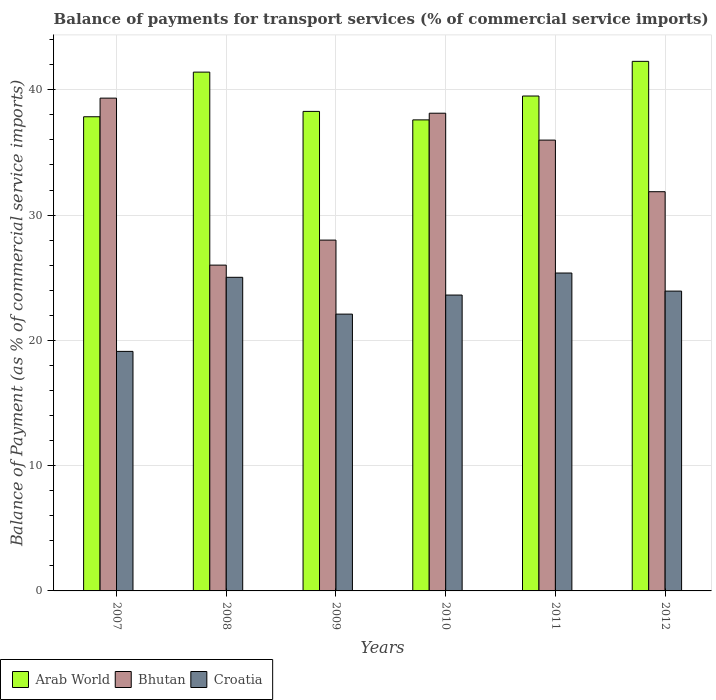Are the number of bars per tick equal to the number of legend labels?
Offer a very short reply. Yes. What is the label of the 5th group of bars from the left?
Your answer should be compact. 2011. What is the balance of payments for transport services in Bhutan in 2010?
Your response must be concise. 38.13. Across all years, what is the maximum balance of payments for transport services in Croatia?
Provide a succinct answer. 25.37. Across all years, what is the minimum balance of payments for transport services in Arab World?
Offer a very short reply. 37.6. In which year was the balance of payments for transport services in Arab World maximum?
Provide a succinct answer. 2012. What is the total balance of payments for transport services in Croatia in the graph?
Ensure brevity in your answer.  139.17. What is the difference between the balance of payments for transport services in Croatia in 2007 and that in 2008?
Provide a short and direct response. -5.91. What is the difference between the balance of payments for transport services in Arab World in 2007 and the balance of payments for transport services in Bhutan in 2012?
Provide a short and direct response. 5.98. What is the average balance of payments for transport services in Arab World per year?
Provide a succinct answer. 39.48. In the year 2007, what is the difference between the balance of payments for transport services in Croatia and balance of payments for transport services in Bhutan?
Provide a short and direct response. -20.21. What is the ratio of the balance of payments for transport services in Arab World in 2009 to that in 2010?
Make the answer very short. 1.02. Is the balance of payments for transport services in Croatia in 2008 less than that in 2009?
Your answer should be compact. No. What is the difference between the highest and the second highest balance of payments for transport services in Arab World?
Provide a succinct answer. 0.86. What is the difference between the highest and the lowest balance of payments for transport services in Arab World?
Keep it short and to the point. 4.67. In how many years, is the balance of payments for transport services in Bhutan greater than the average balance of payments for transport services in Bhutan taken over all years?
Offer a very short reply. 3. Is the sum of the balance of payments for transport services in Arab World in 2010 and 2011 greater than the maximum balance of payments for transport services in Bhutan across all years?
Your response must be concise. Yes. What does the 2nd bar from the left in 2011 represents?
Give a very brief answer. Bhutan. What does the 3rd bar from the right in 2007 represents?
Ensure brevity in your answer.  Arab World. Is it the case that in every year, the sum of the balance of payments for transport services in Croatia and balance of payments for transport services in Arab World is greater than the balance of payments for transport services in Bhutan?
Your response must be concise. Yes. Are all the bars in the graph horizontal?
Offer a terse response. No. How many years are there in the graph?
Keep it short and to the point. 6. What is the difference between two consecutive major ticks on the Y-axis?
Your response must be concise. 10. Are the values on the major ticks of Y-axis written in scientific E-notation?
Your answer should be compact. No. Does the graph contain any zero values?
Offer a very short reply. No. What is the title of the graph?
Ensure brevity in your answer.  Balance of payments for transport services (% of commercial service imports). What is the label or title of the Y-axis?
Keep it short and to the point. Balance of Payment (as % of commercial service imports). What is the Balance of Payment (as % of commercial service imports) of Arab World in 2007?
Keep it short and to the point. 37.85. What is the Balance of Payment (as % of commercial service imports) of Bhutan in 2007?
Keep it short and to the point. 39.33. What is the Balance of Payment (as % of commercial service imports) in Croatia in 2007?
Your answer should be very brief. 19.12. What is the Balance of Payment (as % of commercial service imports) in Arab World in 2008?
Your answer should be compact. 41.41. What is the Balance of Payment (as % of commercial service imports) in Bhutan in 2008?
Provide a short and direct response. 26.01. What is the Balance of Payment (as % of commercial service imports) of Croatia in 2008?
Offer a very short reply. 25.03. What is the Balance of Payment (as % of commercial service imports) of Arab World in 2009?
Offer a very short reply. 38.28. What is the Balance of Payment (as % of commercial service imports) in Bhutan in 2009?
Your response must be concise. 28. What is the Balance of Payment (as % of commercial service imports) in Croatia in 2009?
Keep it short and to the point. 22.1. What is the Balance of Payment (as % of commercial service imports) of Arab World in 2010?
Provide a short and direct response. 37.6. What is the Balance of Payment (as % of commercial service imports) of Bhutan in 2010?
Your answer should be compact. 38.13. What is the Balance of Payment (as % of commercial service imports) in Croatia in 2010?
Provide a short and direct response. 23.62. What is the Balance of Payment (as % of commercial service imports) of Arab World in 2011?
Your answer should be very brief. 39.5. What is the Balance of Payment (as % of commercial service imports) of Bhutan in 2011?
Give a very brief answer. 35.99. What is the Balance of Payment (as % of commercial service imports) of Croatia in 2011?
Keep it short and to the point. 25.37. What is the Balance of Payment (as % of commercial service imports) of Arab World in 2012?
Ensure brevity in your answer.  42.27. What is the Balance of Payment (as % of commercial service imports) in Bhutan in 2012?
Give a very brief answer. 31.87. What is the Balance of Payment (as % of commercial service imports) in Croatia in 2012?
Keep it short and to the point. 23.93. Across all years, what is the maximum Balance of Payment (as % of commercial service imports) in Arab World?
Offer a terse response. 42.27. Across all years, what is the maximum Balance of Payment (as % of commercial service imports) in Bhutan?
Offer a terse response. 39.33. Across all years, what is the maximum Balance of Payment (as % of commercial service imports) of Croatia?
Your answer should be compact. 25.37. Across all years, what is the minimum Balance of Payment (as % of commercial service imports) of Arab World?
Offer a very short reply. 37.6. Across all years, what is the minimum Balance of Payment (as % of commercial service imports) of Bhutan?
Make the answer very short. 26.01. Across all years, what is the minimum Balance of Payment (as % of commercial service imports) in Croatia?
Offer a very short reply. 19.12. What is the total Balance of Payment (as % of commercial service imports) of Arab World in the graph?
Your response must be concise. 236.91. What is the total Balance of Payment (as % of commercial service imports) in Bhutan in the graph?
Make the answer very short. 199.32. What is the total Balance of Payment (as % of commercial service imports) of Croatia in the graph?
Keep it short and to the point. 139.17. What is the difference between the Balance of Payment (as % of commercial service imports) in Arab World in 2007 and that in 2008?
Make the answer very short. -3.56. What is the difference between the Balance of Payment (as % of commercial service imports) of Bhutan in 2007 and that in 2008?
Make the answer very short. 13.33. What is the difference between the Balance of Payment (as % of commercial service imports) in Croatia in 2007 and that in 2008?
Make the answer very short. -5.91. What is the difference between the Balance of Payment (as % of commercial service imports) of Arab World in 2007 and that in 2009?
Offer a very short reply. -0.43. What is the difference between the Balance of Payment (as % of commercial service imports) in Bhutan in 2007 and that in 2009?
Provide a succinct answer. 11.33. What is the difference between the Balance of Payment (as % of commercial service imports) of Croatia in 2007 and that in 2009?
Your response must be concise. -2.98. What is the difference between the Balance of Payment (as % of commercial service imports) of Arab World in 2007 and that in 2010?
Offer a very short reply. 0.25. What is the difference between the Balance of Payment (as % of commercial service imports) of Bhutan in 2007 and that in 2010?
Provide a short and direct response. 1.2. What is the difference between the Balance of Payment (as % of commercial service imports) in Croatia in 2007 and that in 2010?
Make the answer very short. -4.5. What is the difference between the Balance of Payment (as % of commercial service imports) of Arab World in 2007 and that in 2011?
Offer a terse response. -1.66. What is the difference between the Balance of Payment (as % of commercial service imports) in Bhutan in 2007 and that in 2011?
Your response must be concise. 3.35. What is the difference between the Balance of Payment (as % of commercial service imports) of Croatia in 2007 and that in 2011?
Make the answer very short. -6.25. What is the difference between the Balance of Payment (as % of commercial service imports) of Arab World in 2007 and that in 2012?
Your answer should be compact. -4.42. What is the difference between the Balance of Payment (as % of commercial service imports) of Bhutan in 2007 and that in 2012?
Your answer should be compact. 7.47. What is the difference between the Balance of Payment (as % of commercial service imports) in Croatia in 2007 and that in 2012?
Keep it short and to the point. -4.81. What is the difference between the Balance of Payment (as % of commercial service imports) in Arab World in 2008 and that in 2009?
Keep it short and to the point. 3.14. What is the difference between the Balance of Payment (as % of commercial service imports) in Bhutan in 2008 and that in 2009?
Provide a short and direct response. -2. What is the difference between the Balance of Payment (as % of commercial service imports) of Croatia in 2008 and that in 2009?
Give a very brief answer. 2.94. What is the difference between the Balance of Payment (as % of commercial service imports) in Arab World in 2008 and that in 2010?
Your response must be concise. 3.81. What is the difference between the Balance of Payment (as % of commercial service imports) in Bhutan in 2008 and that in 2010?
Offer a very short reply. -12.12. What is the difference between the Balance of Payment (as % of commercial service imports) of Croatia in 2008 and that in 2010?
Offer a very short reply. 1.42. What is the difference between the Balance of Payment (as % of commercial service imports) in Arab World in 2008 and that in 2011?
Provide a short and direct response. 1.91. What is the difference between the Balance of Payment (as % of commercial service imports) in Bhutan in 2008 and that in 2011?
Make the answer very short. -9.98. What is the difference between the Balance of Payment (as % of commercial service imports) in Croatia in 2008 and that in 2011?
Provide a succinct answer. -0.34. What is the difference between the Balance of Payment (as % of commercial service imports) in Arab World in 2008 and that in 2012?
Your answer should be very brief. -0.86. What is the difference between the Balance of Payment (as % of commercial service imports) of Bhutan in 2008 and that in 2012?
Offer a very short reply. -5.86. What is the difference between the Balance of Payment (as % of commercial service imports) in Croatia in 2008 and that in 2012?
Provide a short and direct response. 1.1. What is the difference between the Balance of Payment (as % of commercial service imports) of Arab World in 2009 and that in 2010?
Offer a very short reply. 0.68. What is the difference between the Balance of Payment (as % of commercial service imports) of Bhutan in 2009 and that in 2010?
Your answer should be very brief. -10.13. What is the difference between the Balance of Payment (as % of commercial service imports) in Croatia in 2009 and that in 2010?
Your answer should be very brief. -1.52. What is the difference between the Balance of Payment (as % of commercial service imports) in Arab World in 2009 and that in 2011?
Offer a terse response. -1.23. What is the difference between the Balance of Payment (as % of commercial service imports) of Bhutan in 2009 and that in 2011?
Offer a very short reply. -7.98. What is the difference between the Balance of Payment (as % of commercial service imports) of Croatia in 2009 and that in 2011?
Give a very brief answer. -3.28. What is the difference between the Balance of Payment (as % of commercial service imports) of Arab World in 2009 and that in 2012?
Provide a succinct answer. -3.99. What is the difference between the Balance of Payment (as % of commercial service imports) in Bhutan in 2009 and that in 2012?
Keep it short and to the point. -3.86. What is the difference between the Balance of Payment (as % of commercial service imports) in Croatia in 2009 and that in 2012?
Provide a short and direct response. -1.84. What is the difference between the Balance of Payment (as % of commercial service imports) in Arab World in 2010 and that in 2011?
Your response must be concise. -1.9. What is the difference between the Balance of Payment (as % of commercial service imports) in Bhutan in 2010 and that in 2011?
Give a very brief answer. 2.15. What is the difference between the Balance of Payment (as % of commercial service imports) in Croatia in 2010 and that in 2011?
Offer a terse response. -1.76. What is the difference between the Balance of Payment (as % of commercial service imports) in Arab World in 2010 and that in 2012?
Offer a terse response. -4.67. What is the difference between the Balance of Payment (as % of commercial service imports) of Bhutan in 2010 and that in 2012?
Offer a terse response. 6.27. What is the difference between the Balance of Payment (as % of commercial service imports) of Croatia in 2010 and that in 2012?
Keep it short and to the point. -0.32. What is the difference between the Balance of Payment (as % of commercial service imports) in Arab World in 2011 and that in 2012?
Offer a very short reply. -2.77. What is the difference between the Balance of Payment (as % of commercial service imports) of Bhutan in 2011 and that in 2012?
Ensure brevity in your answer.  4.12. What is the difference between the Balance of Payment (as % of commercial service imports) in Croatia in 2011 and that in 2012?
Your answer should be very brief. 1.44. What is the difference between the Balance of Payment (as % of commercial service imports) in Arab World in 2007 and the Balance of Payment (as % of commercial service imports) in Bhutan in 2008?
Make the answer very short. 11.84. What is the difference between the Balance of Payment (as % of commercial service imports) in Arab World in 2007 and the Balance of Payment (as % of commercial service imports) in Croatia in 2008?
Keep it short and to the point. 12.82. What is the difference between the Balance of Payment (as % of commercial service imports) of Bhutan in 2007 and the Balance of Payment (as % of commercial service imports) of Croatia in 2008?
Offer a terse response. 14.3. What is the difference between the Balance of Payment (as % of commercial service imports) in Arab World in 2007 and the Balance of Payment (as % of commercial service imports) in Bhutan in 2009?
Your answer should be compact. 9.84. What is the difference between the Balance of Payment (as % of commercial service imports) in Arab World in 2007 and the Balance of Payment (as % of commercial service imports) in Croatia in 2009?
Your response must be concise. 15.75. What is the difference between the Balance of Payment (as % of commercial service imports) of Bhutan in 2007 and the Balance of Payment (as % of commercial service imports) of Croatia in 2009?
Offer a very short reply. 17.24. What is the difference between the Balance of Payment (as % of commercial service imports) in Arab World in 2007 and the Balance of Payment (as % of commercial service imports) in Bhutan in 2010?
Provide a succinct answer. -0.28. What is the difference between the Balance of Payment (as % of commercial service imports) of Arab World in 2007 and the Balance of Payment (as % of commercial service imports) of Croatia in 2010?
Offer a terse response. 14.23. What is the difference between the Balance of Payment (as % of commercial service imports) in Bhutan in 2007 and the Balance of Payment (as % of commercial service imports) in Croatia in 2010?
Provide a short and direct response. 15.72. What is the difference between the Balance of Payment (as % of commercial service imports) of Arab World in 2007 and the Balance of Payment (as % of commercial service imports) of Bhutan in 2011?
Your response must be concise. 1.86. What is the difference between the Balance of Payment (as % of commercial service imports) in Arab World in 2007 and the Balance of Payment (as % of commercial service imports) in Croatia in 2011?
Your response must be concise. 12.47. What is the difference between the Balance of Payment (as % of commercial service imports) in Bhutan in 2007 and the Balance of Payment (as % of commercial service imports) in Croatia in 2011?
Give a very brief answer. 13.96. What is the difference between the Balance of Payment (as % of commercial service imports) of Arab World in 2007 and the Balance of Payment (as % of commercial service imports) of Bhutan in 2012?
Offer a terse response. 5.98. What is the difference between the Balance of Payment (as % of commercial service imports) of Arab World in 2007 and the Balance of Payment (as % of commercial service imports) of Croatia in 2012?
Provide a succinct answer. 13.92. What is the difference between the Balance of Payment (as % of commercial service imports) in Bhutan in 2007 and the Balance of Payment (as % of commercial service imports) in Croatia in 2012?
Provide a short and direct response. 15.4. What is the difference between the Balance of Payment (as % of commercial service imports) in Arab World in 2008 and the Balance of Payment (as % of commercial service imports) in Bhutan in 2009?
Provide a succinct answer. 13.41. What is the difference between the Balance of Payment (as % of commercial service imports) of Arab World in 2008 and the Balance of Payment (as % of commercial service imports) of Croatia in 2009?
Your answer should be compact. 19.32. What is the difference between the Balance of Payment (as % of commercial service imports) in Bhutan in 2008 and the Balance of Payment (as % of commercial service imports) in Croatia in 2009?
Offer a terse response. 3.91. What is the difference between the Balance of Payment (as % of commercial service imports) of Arab World in 2008 and the Balance of Payment (as % of commercial service imports) of Bhutan in 2010?
Offer a very short reply. 3.28. What is the difference between the Balance of Payment (as % of commercial service imports) of Arab World in 2008 and the Balance of Payment (as % of commercial service imports) of Croatia in 2010?
Provide a short and direct response. 17.8. What is the difference between the Balance of Payment (as % of commercial service imports) in Bhutan in 2008 and the Balance of Payment (as % of commercial service imports) in Croatia in 2010?
Your answer should be very brief. 2.39. What is the difference between the Balance of Payment (as % of commercial service imports) of Arab World in 2008 and the Balance of Payment (as % of commercial service imports) of Bhutan in 2011?
Ensure brevity in your answer.  5.43. What is the difference between the Balance of Payment (as % of commercial service imports) in Arab World in 2008 and the Balance of Payment (as % of commercial service imports) in Croatia in 2011?
Your answer should be compact. 16.04. What is the difference between the Balance of Payment (as % of commercial service imports) in Bhutan in 2008 and the Balance of Payment (as % of commercial service imports) in Croatia in 2011?
Your answer should be very brief. 0.63. What is the difference between the Balance of Payment (as % of commercial service imports) in Arab World in 2008 and the Balance of Payment (as % of commercial service imports) in Bhutan in 2012?
Offer a very short reply. 9.55. What is the difference between the Balance of Payment (as % of commercial service imports) of Arab World in 2008 and the Balance of Payment (as % of commercial service imports) of Croatia in 2012?
Ensure brevity in your answer.  17.48. What is the difference between the Balance of Payment (as % of commercial service imports) of Bhutan in 2008 and the Balance of Payment (as % of commercial service imports) of Croatia in 2012?
Offer a very short reply. 2.07. What is the difference between the Balance of Payment (as % of commercial service imports) in Arab World in 2009 and the Balance of Payment (as % of commercial service imports) in Bhutan in 2010?
Offer a very short reply. 0.15. What is the difference between the Balance of Payment (as % of commercial service imports) of Arab World in 2009 and the Balance of Payment (as % of commercial service imports) of Croatia in 2010?
Your answer should be compact. 14.66. What is the difference between the Balance of Payment (as % of commercial service imports) of Bhutan in 2009 and the Balance of Payment (as % of commercial service imports) of Croatia in 2010?
Your answer should be compact. 4.39. What is the difference between the Balance of Payment (as % of commercial service imports) in Arab World in 2009 and the Balance of Payment (as % of commercial service imports) in Bhutan in 2011?
Your answer should be compact. 2.29. What is the difference between the Balance of Payment (as % of commercial service imports) in Arab World in 2009 and the Balance of Payment (as % of commercial service imports) in Croatia in 2011?
Give a very brief answer. 12.9. What is the difference between the Balance of Payment (as % of commercial service imports) in Bhutan in 2009 and the Balance of Payment (as % of commercial service imports) in Croatia in 2011?
Provide a succinct answer. 2.63. What is the difference between the Balance of Payment (as % of commercial service imports) of Arab World in 2009 and the Balance of Payment (as % of commercial service imports) of Bhutan in 2012?
Your answer should be very brief. 6.41. What is the difference between the Balance of Payment (as % of commercial service imports) in Arab World in 2009 and the Balance of Payment (as % of commercial service imports) in Croatia in 2012?
Give a very brief answer. 14.34. What is the difference between the Balance of Payment (as % of commercial service imports) in Bhutan in 2009 and the Balance of Payment (as % of commercial service imports) in Croatia in 2012?
Your response must be concise. 4.07. What is the difference between the Balance of Payment (as % of commercial service imports) of Arab World in 2010 and the Balance of Payment (as % of commercial service imports) of Bhutan in 2011?
Offer a terse response. 1.61. What is the difference between the Balance of Payment (as % of commercial service imports) in Arab World in 2010 and the Balance of Payment (as % of commercial service imports) in Croatia in 2011?
Make the answer very short. 12.22. What is the difference between the Balance of Payment (as % of commercial service imports) of Bhutan in 2010 and the Balance of Payment (as % of commercial service imports) of Croatia in 2011?
Your response must be concise. 12.76. What is the difference between the Balance of Payment (as % of commercial service imports) in Arab World in 2010 and the Balance of Payment (as % of commercial service imports) in Bhutan in 2012?
Give a very brief answer. 5.73. What is the difference between the Balance of Payment (as % of commercial service imports) in Arab World in 2010 and the Balance of Payment (as % of commercial service imports) in Croatia in 2012?
Offer a terse response. 13.67. What is the difference between the Balance of Payment (as % of commercial service imports) of Bhutan in 2010 and the Balance of Payment (as % of commercial service imports) of Croatia in 2012?
Offer a very short reply. 14.2. What is the difference between the Balance of Payment (as % of commercial service imports) of Arab World in 2011 and the Balance of Payment (as % of commercial service imports) of Bhutan in 2012?
Make the answer very short. 7.64. What is the difference between the Balance of Payment (as % of commercial service imports) of Arab World in 2011 and the Balance of Payment (as % of commercial service imports) of Croatia in 2012?
Provide a succinct answer. 15.57. What is the difference between the Balance of Payment (as % of commercial service imports) in Bhutan in 2011 and the Balance of Payment (as % of commercial service imports) in Croatia in 2012?
Give a very brief answer. 12.05. What is the average Balance of Payment (as % of commercial service imports) in Arab World per year?
Provide a succinct answer. 39.48. What is the average Balance of Payment (as % of commercial service imports) of Bhutan per year?
Provide a short and direct response. 33.22. What is the average Balance of Payment (as % of commercial service imports) of Croatia per year?
Provide a short and direct response. 23.2. In the year 2007, what is the difference between the Balance of Payment (as % of commercial service imports) in Arab World and Balance of Payment (as % of commercial service imports) in Bhutan?
Offer a terse response. -1.49. In the year 2007, what is the difference between the Balance of Payment (as % of commercial service imports) in Arab World and Balance of Payment (as % of commercial service imports) in Croatia?
Offer a very short reply. 18.73. In the year 2007, what is the difference between the Balance of Payment (as % of commercial service imports) in Bhutan and Balance of Payment (as % of commercial service imports) in Croatia?
Your answer should be very brief. 20.21. In the year 2008, what is the difference between the Balance of Payment (as % of commercial service imports) of Arab World and Balance of Payment (as % of commercial service imports) of Bhutan?
Provide a short and direct response. 15.41. In the year 2008, what is the difference between the Balance of Payment (as % of commercial service imports) of Arab World and Balance of Payment (as % of commercial service imports) of Croatia?
Make the answer very short. 16.38. In the year 2008, what is the difference between the Balance of Payment (as % of commercial service imports) of Bhutan and Balance of Payment (as % of commercial service imports) of Croatia?
Make the answer very short. 0.97. In the year 2009, what is the difference between the Balance of Payment (as % of commercial service imports) of Arab World and Balance of Payment (as % of commercial service imports) of Bhutan?
Your answer should be compact. 10.27. In the year 2009, what is the difference between the Balance of Payment (as % of commercial service imports) in Arab World and Balance of Payment (as % of commercial service imports) in Croatia?
Ensure brevity in your answer.  16.18. In the year 2009, what is the difference between the Balance of Payment (as % of commercial service imports) of Bhutan and Balance of Payment (as % of commercial service imports) of Croatia?
Provide a succinct answer. 5.91. In the year 2010, what is the difference between the Balance of Payment (as % of commercial service imports) in Arab World and Balance of Payment (as % of commercial service imports) in Bhutan?
Provide a short and direct response. -0.53. In the year 2010, what is the difference between the Balance of Payment (as % of commercial service imports) in Arab World and Balance of Payment (as % of commercial service imports) in Croatia?
Offer a very short reply. 13.98. In the year 2010, what is the difference between the Balance of Payment (as % of commercial service imports) of Bhutan and Balance of Payment (as % of commercial service imports) of Croatia?
Your answer should be very brief. 14.51. In the year 2011, what is the difference between the Balance of Payment (as % of commercial service imports) in Arab World and Balance of Payment (as % of commercial service imports) in Bhutan?
Keep it short and to the point. 3.52. In the year 2011, what is the difference between the Balance of Payment (as % of commercial service imports) in Arab World and Balance of Payment (as % of commercial service imports) in Croatia?
Your response must be concise. 14.13. In the year 2011, what is the difference between the Balance of Payment (as % of commercial service imports) of Bhutan and Balance of Payment (as % of commercial service imports) of Croatia?
Your response must be concise. 10.61. In the year 2012, what is the difference between the Balance of Payment (as % of commercial service imports) of Arab World and Balance of Payment (as % of commercial service imports) of Bhutan?
Make the answer very short. 10.4. In the year 2012, what is the difference between the Balance of Payment (as % of commercial service imports) of Arab World and Balance of Payment (as % of commercial service imports) of Croatia?
Offer a terse response. 18.34. In the year 2012, what is the difference between the Balance of Payment (as % of commercial service imports) of Bhutan and Balance of Payment (as % of commercial service imports) of Croatia?
Offer a very short reply. 7.93. What is the ratio of the Balance of Payment (as % of commercial service imports) of Arab World in 2007 to that in 2008?
Provide a succinct answer. 0.91. What is the ratio of the Balance of Payment (as % of commercial service imports) in Bhutan in 2007 to that in 2008?
Make the answer very short. 1.51. What is the ratio of the Balance of Payment (as % of commercial service imports) of Croatia in 2007 to that in 2008?
Your answer should be very brief. 0.76. What is the ratio of the Balance of Payment (as % of commercial service imports) of Arab World in 2007 to that in 2009?
Provide a short and direct response. 0.99. What is the ratio of the Balance of Payment (as % of commercial service imports) of Bhutan in 2007 to that in 2009?
Provide a succinct answer. 1.4. What is the ratio of the Balance of Payment (as % of commercial service imports) of Croatia in 2007 to that in 2009?
Your answer should be compact. 0.87. What is the ratio of the Balance of Payment (as % of commercial service imports) in Arab World in 2007 to that in 2010?
Give a very brief answer. 1.01. What is the ratio of the Balance of Payment (as % of commercial service imports) in Bhutan in 2007 to that in 2010?
Offer a terse response. 1.03. What is the ratio of the Balance of Payment (as % of commercial service imports) in Croatia in 2007 to that in 2010?
Provide a succinct answer. 0.81. What is the ratio of the Balance of Payment (as % of commercial service imports) of Arab World in 2007 to that in 2011?
Your answer should be very brief. 0.96. What is the ratio of the Balance of Payment (as % of commercial service imports) in Bhutan in 2007 to that in 2011?
Your response must be concise. 1.09. What is the ratio of the Balance of Payment (as % of commercial service imports) in Croatia in 2007 to that in 2011?
Offer a very short reply. 0.75. What is the ratio of the Balance of Payment (as % of commercial service imports) in Arab World in 2007 to that in 2012?
Ensure brevity in your answer.  0.9. What is the ratio of the Balance of Payment (as % of commercial service imports) of Bhutan in 2007 to that in 2012?
Ensure brevity in your answer.  1.23. What is the ratio of the Balance of Payment (as % of commercial service imports) of Croatia in 2007 to that in 2012?
Make the answer very short. 0.8. What is the ratio of the Balance of Payment (as % of commercial service imports) of Arab World in 2008 to that in 2009?
Your answer should be very brief. 1.08. What is the ratio of the Balance of Payment (as % of commercial service imports) in Bhutan in 2008 to that in 2009?
Provide a succinct answer. 0.93. What is the ratio of the Balance of Payment (as % of commercial service imports) in Croatia in 2008 to that in 2009?
Give a very brief answer. 1.13. What is the ratio of the Balance of Payment (as % of commercial service imports) in Arab World in 2008 to that in 2010?
Provide a short and direct response. 1.1. What is the ratio of the Balance of Payment (as % of commercial service imports) in Bhutan in 2008 to that in 2010?
Keep it short and to the point. 0.68. What is the ratio of the Balance of Payment (as % of commercial service imports) in Croatia in 2008 to that in 2010?
Provide a succinct answer. 1.06. What is the ratio of the Balance of Payment (as % of commercial service imports) in Arab World in 2008 to that in 2011?
Give a very brief answer. 1.05. What is the ratio of the Balance of Payment (as % of commercial service imports) in Bhutan in 2008 to that in 2011?
Make the answer very short. 0.72. What is the ratio of the Balance of Payment (as % of commercial service imports) in Croatia in 2008 to that in 2011?
Offer a very short reply. 0.99. What is the ratio of the Balance of Payment (as % of commercial service imports) in Arab World in 2008 to that in 2012?
Your response must be concise. 0.98. What is the ratio of the Balance of Payment (as % of commercial service imports) of Bhutan in 2008 to that in 2012?
Your response must be concise. 0.82. What is the ratio of the Balance of Payment (as % of commercial service imports) of Croatia in 2008 to that in 2012?
Keep it short and to the point. 1.05. What is the ratio of the Balance of Payment (as % of commercial service imports) of Arab World in 2009 to that in 2010?
Give a very brief answer. 1.02. What is the ratio of the Balance of Payment (as % of commercial service imports) in Bhutan in 2009 to that in 2010?
Make the answer very short. 0.73. What is the ratio of the Balance of Payment (as % of commercial service imports) of Croatia in 2009 to that in 2010?
Offer a very short reply. 0.94. What is the ratio of the Balance of Payment (as % of commercial service imports) of Arab World in 2009 to that in 2011?
Ensure brevity in your answer.  0.97. What is the ratio of the Balance of Payment (as % of commercial service imports) of Bhutan in 2009 to that in 2011?
Offer a very short reply. 0.78. What is the ratio of the Balance of Payment (as % of commercial service imports) of Croatia in 2009 to that in 2011?
Provide a succinct answer. 0.87. What is the ratio of the Balance of Payment (as % of commercial service imports) of Arab World in 2009 to that in 2012?
Provide a succinct answer. 0.91. What is the ratio of the Balance of Payment (as % of commercial service imports) in Bhutan in 2009 to that in 2012?
Make the answer very short. 0.88. What is the ratio of the Balance of Payment (as % of commercial service imports) of Croatia in 2009 to that in 2012?
Offer a very short reply. 0.92. What is the ratio of the Balance of Payment (as % of commercial service imports) of Arab World in 2010 to that in 2011?
Offer a terse response. 0.95. What is the ratio of the Balance of Payment (as % of commercial service imports) of Bhutan in 2010 to that in 2011?
Ensure brevity in your answer.  1.06. What is the ratio of the Balance of Payment (as % of commercial service imports) of Croatia in 2010 to that in 2011?
Offer a terse response. 0.93. What is the ratio of the Balance of Payment (as % of commercial service imports) in Arab World in 2010 to that in 2012?
Your answer should be very brief. 0.89. What is the ratio of the Balance of Payment (as % of commercial service imports) of Bhutan in 2010 to that in 2012?
Keep it short and to the point. 1.2. What is the ratio of the Balance of Payment (as % of commercial service imports) in Arab World in 2011 to that in 2012?
Provide a succinct answer. 0.93. What is the ratio of the Balance of Payment (as % of commercial service imports) in Bhutan in 2011 to that in 2012?
Offer a terse response. 1.13. What is the ratio of the Balance of Payment (as % of commercial service imports) in Croatia in 2011 to that in 2012?
Provide a short and direct response. 1.06. What is the difference between the highest and the second highest Balance of Payment (as % of commercial service imports) of Arab World?
Your response must be concise. 0.86. What is the difference between the highest and the second highest Balance of Payment (as % of commercial service imports) of Bhutan?
Your answer should be very brief. 1.2. What is the difference between the highest and the second highest Balance of Payment (as % of commercial service imports) of Croatia?
Your answer should be very brief. 0.34. What is the difference between the highest and the lowest Balance of Payment (as % of commercial service imports) in Arab World?
Provide a short and direct response. 4.67. What is the difference between the highest and the lowest Balance of Payment (as % of commercial service imports) in Bhutan?
Provide a short and direct response. 13.33. What is the difference between the highest and the lowest Balance of Payment (as % of commercial service imports) of Croatia?
Make the answer very short. 6.25. 